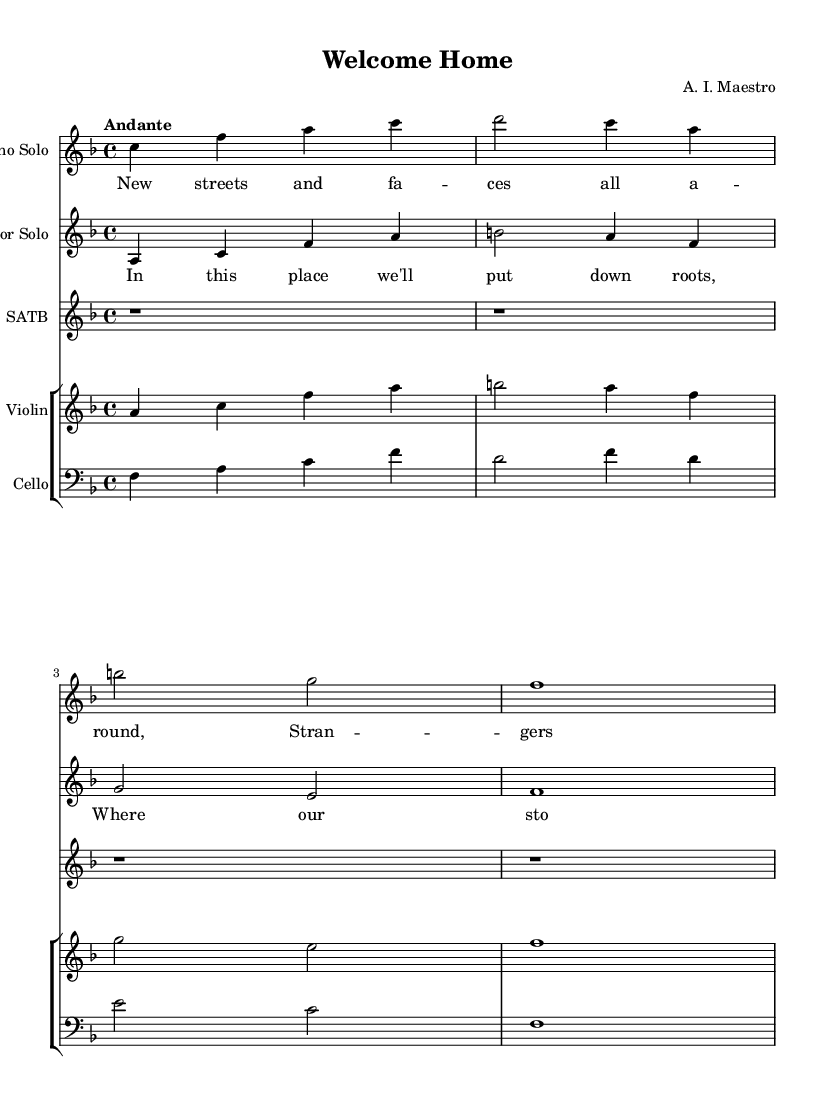What is the key signature of this music? The key signature is F major, which contains one flat (B flat). It is noted at the beginning of the staff after the clef symbol.
Answer: F major What is the time signature of this music? The time signature is 4/4, indicated at the beginning of the score. This means there are four beats in each measure and a quarter note receives one beat.
Answer: 4/4 What is the tempo marking for this piece? The tempo marking given is "Andante", which suggests a moderate pace. The tempo is usually indicated at the start of the score above the first measure.
Answer: Andante How many measures are there in the Soprano Solo? There are four measures present in the Soprano Solo as indicated by the grouping of notes within the vertical lines. Each vertical line represents the end of a measure.
Answer: Four What type of ensemble is indicated in this piece? The piece includes a "Soprano Solo," "Tenor Solo," and "SATB" choir, signifying it is written for solo singers and a choir ensemble. This type of ensemble composition is typical of opera.
Answer: SATB choir What is the last note of the Cello part? The last note of the Cello part is F, which can be found in the final measure of the Cello section. The note corresponds to the bass clef notation at the end.
Answer: F 